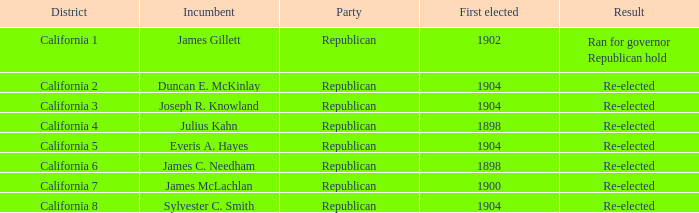What's the highest First Elected with a Result of Re-elected and DIstrict of California 5? 1904.0. 